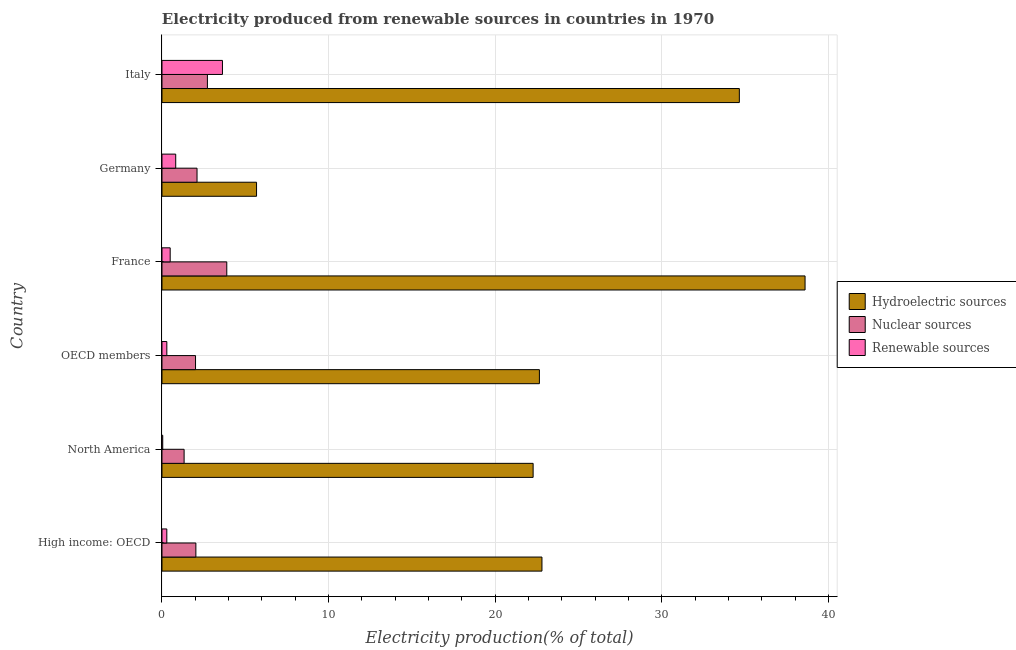How many groups of bars are there?
Your response must be concise. 6. Are the number of bars per tick equal to the number of legend labels?
Ensure brevity in your answer.  Yes. How many bars are there on the 5th tick from the top?
Your answer should be very brief. 3. How many bars are there on the 1st tick from the bottom?
Keep it short and to the point. 3. What is the label of the 2nd group of bars from the top?
Offer a terse response. Germany. In how many cases, is the number of bars for a given country not equal to the number of legend labels?
Ensure brevity in your answer.  0. What is the percentage of electricity produced by hydroelectric sources in Germany?
Your response must be concise. 5.68. Across all countries, what is the maximum percentage of electricity produced by renewable sources?
Your answer should be compact. 3.63. Across all countries, what is the minimum percentage of electricity produced by renewable sources?
Ensure brevity in your answer.  0.04. What is the total percentage of electricity produced by renewable sources in the graph?
Your answer should be compact. 5.57. What is the difference between the percentage of electricity produced by nuclear sources in High income: OECD and that in OECD members?
Offer a very short reply. 0.02. What is the difference between the percentage of electricity produced by renewable sources in OECD members and the percentage of electricity produced by hydroelectric sources in Germany?
Offer a terse response. -5.39. What is the average percentage of electricity produced by hydroelectric sources per country?
Offer a very short reply. 24.45. What is the difference between the percentage of electricity produced by hydroelectric sources and percentage of electricity produced by nuclear sources in High income: OECD?
Offer a very short reply. 20.77. What is the ratio of the percentage of electricity produced by renewable sources in Germany to that in High income: OECD?
Your response must be concise. 2.85. Is the percentage of electricity produced by renewable sources in Germany less than that in Italy?
Provide a short and direct response. Yes. What is the difference between the highest and the second highest percentage of electricity produced by hydroelectric sources?
Your answer should be compact. 3.94. What is the difference between the highest and the lowest percentage of electricity produced by hydroelectric sources?
Provide a short and direct response. 32.92. In how many countries, is the percentage of electricity produced by nuclear sources greater than the average percentage of electricity produced by nuclear sources taken over all countries?
Give a very brief answer. 2. Is the sum of the percentage of electricity produced by nuclear sources in Italy and OECD members greater than the maximum percentage of electricity produced by hydroelectric sources across all countries?
Give a very brief answer. No. What does the 3rd bar from the top in High income: OECD represents?
Give a very brief answer. Hydroelectric sources. What does the 1st bar from the bottom in France represents?
Offer a very short reply. Hydroelectric sources. How many bars are there?
Provide a succinct answer. 18. What is the difference between two consecutive major ticks on the X-axis?
Provide a short and direct response. 10. Are the values on the major ticks of X-axis written in scientific E-notation?
Offer a terse response. No. Does the graph contain grids?
Keep it short and to the point. Yes. How are the legend labels stacked?
Keep it short and to the point. Vertical. What is the title of the graph?
Provide a short and direct response. Electricity produced from renewable sources in countries in 1970. What is the label or title of the Y-axis?
Keep it short and to the point. Country. What is the Electricity production(% of total) of Hydroelectric sources in High income: OECD?
Keep it short and to the point. 22.81. What is the Electricity production(% of total) of Nuclear sources in High income: OECD?
Keep it short and to the point. 2.03. What is the Electricity production(% of total) in Renewable sources in High income: OECD?
Your answer should be compact. 0.29. What is the Electricity production(% of total) of Hydroelectric sources in North America?
Ensure brevity in your answer.  22.28. What is the Electricity production(% of total) in Nuclear sources in North America?
Offer a terse response. 1.33. What is the Electricity production(% of total) of Renewable sources in North America?
Offer a very short reply. 0.04. What is the Electricity production(% of total) in Hydroelectric sources in OECD members?
Ensure brevity in your answer.  22.65. What is the Electricity production(% of total) of Nuclear sources in OECD members?
Make the answer very short. 2.01. What is the Electricity production(% of total) of Renewable sources in OECD members?
Ensure brevity in your answer.  0.29. What is the Electricity production(% of total) of Hydroelectric sources in France?
Your answer should be very brief. 38.6. What is the Electricity production(% of total) in Nuclear sources in France?
Make the answer very short. 3.89. What is the Electricity production(% of total) in Renewable sources in France?
Give a very brief answer. 0.49. What is the Electricity production(% of total) of Hydroelectric sources in Germany?
Give a very brief answer. 5.68. What is the Electricity production(% of total) in Nuclear sources in Germany?
Your answer should be compact. 2.1. What is the Electricity production(% of total) of Renewable sources in Germany?
Keep it short and to the point. 0.82. What is the Electricity production(% of total) in Hydroelectric sources in Italy?
Offer a terse response. 34.66. What is the Electricity production(% of total) of Nuclear sources in Italy?
Offer a terse response. 2.73. What is the Electricity production(% of total) of Renewable sources in Italy?
Your response must be concise. 3.63. Across all countries, what is the maximum Electricity production(% of total) in Hydroelectric sources?
Your answer should be compact. 38.6. Across all countries, what is the maximum Electricity production(% of total) of Nuclear sources?
Ensure brevity in your answer.  3.89. Across all countries, what is the maximum Electricity production(% of total) of Renewable sources?
Keep it short and to the point. 3.63. Across all countries, what is the minimum Electricity production(% of total) of Hydroelectric sources?
Your answer should be very brief. 5.68. Across all countries, what is the minimum Electricity production(% of total) of Nuclear sources?
Offer a very short reply. 1.33. Across all countries, what is the minimum Electricity production(% of total) of Renewable sources?
Your answer should be compact. 0.04. What is the total Electricity production(% of total) of Hydroelectric sources in the graph?
Offer a terse response. 146.67. What is the total Electricity production(% of total) of Nuclear sources in the graph?
Provide a short and direct response. 14.1. What is the total Electricity production(% of total) in Renewable sources in the graph?
Keep it short and to the point. 5.57. What is the difference between the Electricity production(% of total) of Hydroelectric sources in High income: OECD and that in North America?
Offer a terse response. 0.53. What is the difference between the Electricity production(% of total) in Nuclear sources in High income: OECD and that in North America?
Ensure brevity in your answer.  0.71. What is the difference between the Electricity production(% of total) in Renewable sources in High income: OECD and that in North America?
Make the answer very short. 0.24. What is the difference between the Electricity production(% of total) in Hydroelectric sources in High income: OECD and that in OECD members?
Provide a short and direct response. 0.15. What is the difference between the Electricity production(% of total) of Nuclear sources in High income: OECD and that in OECD members?
Provide a short and direct response. 0.02. What is the difference between the Electricity production(% of total) of Renewable sources in High income: OECD and that in OECD members?
Ensure brevity in your answer.  -0. What is the difference between the Electricity production(% of total) of Hydroelectric sources in High income: OECD and that in France?
Provide a succinct answer. -15.79. What is the difference between the Electricity production(% of total) in Nuclear sources in High income: OECD and that in France?
Provide a short and direct response. -1.86. What is the difference between the Electricity production(% of total) in Renewable sources in High income: OECD and that in France?
Your answer should be very brief. -0.2. What is the difference between the Electricity production(% of total) in Hydroelectric sources in High income: OECD and that in Germany?
Ensure brevity in your answer.  17.13. What is the difference between the Electricity production(% of total) in Nuclear sources in High income: OECD and that in Germany?
Offer a terse response. -0.07. What is the difference between the Electricity production(% of total) in Renewable sources in High income: OECD and that in Germany?
Your response must be concise. -0.53. What is the difference between the Electricity production(% of total) in Hydroelectric sources in High income: OECD and that in Italy?
Offer a very short reply. -11.85. What is the difference between the Electricity production(% of total) in Nuclear sources in High income: OECD and that in Italy?
Your answer should be compact. -0.69. What is the difference between the Electricity production(% of total) in Renewable sources in High income: OECD and that in Italy?
Ensure brevity in your answer.  -3.34. What is the difference between the Electricity production(% of total) in Hydroelectric sources in North America and that in OECD members?
Your answer should be compact. -0.38. What is the difference between the Electricity production(% of total) of Nuclear sources in North America and that in OECD members?
Ensure brevity in your answer.  -0.69. What is the difference between the Electricity production(% of total) in Renewable sources in North America and that in OECD members?
Your answer should be compact. -0.25. What is the difference between the Electricity production(% of total) in Hydroelectric sources in North America and that in France?
Make the answer very short. -16.32. What is the difference between the Electricity production(% of total) in Nuclear sources in North America and that in France?
Keep it short and to the point. -2.56. What is the difference between the Electricity production(% of total) in Renewable sources in North America and that in France?
Keep it short and to the point. -0.45. What is the difference between the Electricity production(% of total) in Hydroelectric sources in North America and that in Germany?
Offer a terse response. 16.6. What is the difference between the Electricity production(% of total) of Nuclear sources in North America and that in Germany?
Your response must be concise. -0.78. What is the difference between the Electricity production(% of total) of Renewable sources in North America and that in Germany?
Your answer should be compact. -0.78. What is the difference between the Electricity production(% of total) in Hydroelectric sources in North America and that in Italy?
Your answer should be compact. -12.38. What is the difference between the Electricity production(% of total) of Nuclear sources in North America and that in Italy?
Your answer should be very brief. -1.4. What is the difference between the Electricity production(% of total) of Renewable sources in North America and that in Italy?
Your response must be concise. -3.58. What is the difference between the Electricity production(% of total) in Hydroelectric sources in OECD members and that in France?
Offer a very short reply. -15.95. What is the difference between the Electricity production(% of total) of Nuclear sources in OECD members and that in France?
Provide a succinct answer. -1.88. What is the difference between the Electricity production(% of total) of Renewable sources in OECD members and that in France?
Provide a short and direct response. -0.2. What is the difference between the Electricity production(% of total) in Hydroelectric sources in OECD members and that in Germany?
Ensure brevity in your answer.  16.98. What is the difference between the Electricity production(% of total) of Nuclear sources in OECD members and that in Germany?
Give a very brief answer. -0.09. What is the difference between the Electricity production(% of total) in Renewable sources in OECD members and that in Germany?
Offer a terse response. -0.53. What is the difference between the Electricity production(% of total) in Hydroelectric sources in OECD members and that in Italy?
Offer a very short reply. -12. What is the difference between the Electricity production(% of total) of Nuclear sources in OECD members and that in Italy?
Make the answer very short. -0.71. What is the difference between the Electricity production(% of total) in Renewable sources in OECD members and that in Italy?
Ensure brevity in your answer.  -3.34. What is the difference between the Electricity production(% of total) of Hydroelectric sources in France and that in Germany?
Make the answer very short. 32.92. What is the difference between the Electricity production(% of total) of Nuclear sources in France and that in Germany?
Provide a short and direct response. 1.79. What is the difference between the Electricity production(% of total) in Renewable sources in France and that in Germany?
Provide a succinct answer. -0.33. What is the difference between the Electricity production(% of total) of Hydroelectric sources in France and that in Italy?
Offer a terse response. 3.94. What is the difference between the Electricity production(% of total) of Nuclear sources in France and that in Italy?
Ensure brevity in your answer.  1.16. What is the difference between the Electricity production(% of total) of Renewable sources in France and that in Italy?
Ensure brevity in your answer.  -3.14. What is the difference between the Electricity production(% of total) of Hydroelectric sources in Germany and that in Italy?
Offer a very short reply. -28.98. What is the difference between the Electricity production(% of total) in Nuclear sources in Germany and that in Italy?
Your answer should be compact. -0.62. What is the difference between the Electricity production(% of total) in Renewable sources in Germany and that in Italy?
Provide a short and direct response. -2.81. What is the difference between the Electricity production(% of total) of Hydroelectric sources in High income: OECD and the Electricity production(% of total) of Nuclear sources in North America?
Your answer should be compact. 21.48. What is the difference between the Electricity production(% of total) in Hydroelectric sources in High income: OECD and the Electricity production(% of total) in Renewable sources in North America?
Your answer should be very brief. 22.76. What is the difference between the Electricity production(% of total) in Nuclear sources in High income: OECD and the Electricity production(% of total) in Renewable sources in North America?
Make the answer very short. 1.99. What is the difference between the Electricity production(% of total) of Hydroelectric sources in High income: OECD and the Electricity production(% of total) of Nuclear sources in OECD members?
Your response must be concise. 20.79. What is the difference between the Electricity production(% of total) of Hydroelectric sources in High income: OECD and the Electricity production(% of total) of Renewable sources in OECD members?
Your response must be concise. 22.52. What is the difference between the Electricity production(% of total) of Nuclear sources in High income: OECD and the Electricity production(% of total) of Renewable sources in OECD members?
Your answer should be very brief. 1.74. What is the difference between the Electricity production(% of total) of Hydroelectric sources in High income: OECD and the Electricity production(% of total) of Nuclear sources in France?
Provide a succinct answer. 18.92. What is the difference between the Electricity production(% of total) in Hydroelectric sources in High income: OECD and the Electricity production(% of total) in Renewable sources in France?
Give a very brief answer. 22.32. What is the difference between the Electricity production(% of total) of Nuclear sources in High income: OECD and the Electricity production(% of total) of Renewable sources in France?
Keep it short and to the point. 1.54. What is the difference between the Electricity production(% of total) of Hydroelectric sources in High income: OECD and the Electricity production(% of total) of Nuclear sources in Germany?
Provide a short and direct response. 20.7. What is the difference between the Electricity production(% of total) in Hydroelectric sources in High income: OECD and the Electricity production(% of total) in Renewable sources in Germany?
Your answer should be compact. 21.98. What is the difference between the Electricity production(% of total) of Nuclear sources in High income: OECD and the Electricity production(% of total) of Renewable sources in Germany?
Offer a very short reply. 1.21. What is the difference between the Electricity production(% of total) of Hydroelectric sources in High income: OECD and the Electricity production(% of total) of Nuclear sources in Italy?
Your response must be concise. 20.08. What is the difference between the Electricity production(% of total) of Hydroelectric sources in High income: OECD and the Electricity production(% of total) of Renewable sources in Italy?
Make the answer very short. 19.18. What is the difference between the Electricity production(% of total) of Nuclear sources in High income: OECD and the Electricity production(% of total) of Renewable sources in Italy?
Keep it short and to the point. -1.59. What is the difference between the Electricity production(% of total) of Hydroelectric sources in North America and the Electricity production(% of total) of Nuclear sources in OECD members?
Offer a terse response. 20.26. What is the difference between the Electricity production(% of total) of Hydroelectric sources in North America and the Electricity production(% of total) of Renewable sources in OECD members?
Offer a terse response. 21.99. What is the difference between the Electricity production(% of total) of Nuclear sources in North America and the Electricity production(% of total) of Renewable sources in OECD members?
Keep it short and to the point. 1.04. What is the difference between the Electricity production(% of total) of Hydroelectric sources in North America and the Electricity production(% of total) of Nuclear sources in France?
Give a very brief answer. 18.39. What is the difference between the Electricity production(% of total) of Hydroelectric sources in North America and the Electricity production(% of total) of Renewable sources in France?
Provide a succinct answer. 21.79. What is the difference between the Electricity production(% of total) of Nuclear sources in North America and the Electricity production(% of total) of Renewable sources in France?
Offer a terse response. 0.84. What is the difference between the Electricity production(% of total) of Hydroelectric sources in North America and the Electricity production(% of total) of Nuclear sources in Germany?
Keep it short and to the point. 20.17. What is the difference between the Electricity production(% of total) in Hydroelectric sources in North America and the Electricity production(% of total) in Renewable sources in Germany?
Keep it short and to the point. 21.45. What is the difference between the Electricity production(% of total) of Nuclear sources in North America and the Electricity production(% of total) of Renewable sources in Germany?
Give a very brief answer. 0.5. What is the difference between the Electricity production(% of total) of Hydroelectric sources in North America and the Electricity production(% of total) of Nuclear sources in Italy?
Make the answer very short. 19.55. What is the difference between the Electricity production(% of total) in Hydroelectric sources in North America and the Electricity production(% of total) in Renewable sources in Italy?
Offer a terse response. 18.65. What is the difference between the Electricity production(% of total) of Nuclear sources in North America and the Electricity production(% of total) of Renewable sources in Italy?
Provide a succinct answer. -2.3. What is the difference between the Electricity production(% of total) of Hydroelectric sources in OECD members and the Electricity production(% of total) of Nuclear sources in France?
Offer a very short reply. 18.76. What is the difference between the Electricity production(% of total) in Hydroelectric sources in OECD members and the Electricity production(% of total) in Renewable sources in France?
Make the answer very short. 22.16. What is the difference between the Electricity production(% of total) in Nuclear sources in OECD members and the Electricity production(% of total) in Renewable sources in France?
Ensure brevity in your answer.  1.52. What is the difference between the Electricity production(% of total) in Hydroelectric sources in OECD members and the Electricity production(% of total) in Nuclear sources in Germany?
Offer a very short reply. 20.55. What is the difference between the Electricity production(% of total) of Hydroelectric sources in OECD members and the Electricity production(% of total) of Renewable sources in Germany?
Make the answer very short. 21.83. What is the difference between the Electricity production(% of total) in Nuclear sources in OECD members and the Electricity production(% of total) in Renewable sources in Germany?
Your response must be concise. 1.19. What is the difference between the Electricity production(% of total) of Hydroelectric sources in OECD members and the Electricity production(% of total) of Nuclear sources in Italy?
Your answer should be compact. 19.93. What is the difference between the Electricity production(% of total) of Hydroelectric sources in OECD members and the Electricity production(% of total) of Renewable sources in Italy?
Provide a short and direct response. 19.03. What is the difference between the Electricity production(% of total) in Nuclear sources in OECD members and the Electricity production(% of total) in Renewable sources in Italy?
Keep it short and to the point. -1.62. What is the difference between the Electricity production(% of total) of Hydroelectric sources in France and the Electricity production(% of total) of Nuclear sources in Germany?
Keep it short and to the point. 36.5. What is the difference between the Electricity production(% of total) in Hydroelectric sources in France and the Electricity production(% of total) in Renewable sources in Germany?
Keep it short and to the point. 37.78. What is the difference between the Electricity production(% of total) of Nuclear sources in France and the Electricity production(% of total) of Renewable sources in Germany?
Provide a short and direct response. 3.07. What is the difference between the Electricity production(% of total) in Hydroelectric sources in France and the Electricity production(% of total) in Nuclear sources in Italy?
Your answer should be compact. 35.87. What is the difference between the Electricity production(% of total) of Hydroelectric sources in France and the Electricity production(% of total) of Renewable sources in Italy?
Your answer should be compact. 34.97. What is the difference between the Electricity production(% of total) of Nuclear sources in France and the Electricity production(% of total) of Renewable sources in Italy?
Make the answer very short. 0.26. What is the difference between the Electricity production(% of total) in Hydroelectric sources in Germany and the Electricity production(% of total) in Nuclear sources in Italy?
Keep it short and to the point. 2.95. What is the difference between the Electricity production(% of total) of Hydroelectric sources in Germany and the Electricity production(% of total) of Renewable sources in Italy?
Offer a very short reply. 2.05. What is the difference between the Electricity production(% of total) of Nuclear sources in Germany and the Electricity production(% of total) of Renewable sources in Italy?
Give a very brief answer. -1.53. What is the average Electricity production(% of total) in Hydroelectric sources per country?
Ensure brevity in your answer.  24.45. What is the average Electricity production(% of total) in Nuclear sources per country?
Make the answer very short. 2.35. What is the average Electricity production(% of total) in Renewable sources per country?
Provide a succinct answer. 0.93. What is the difference between the Electricity production(% of total) in Hydroelectric sources and Electricity production(% of total) in Nuclear sources in High income: OECD?
Offer a terse response. 20.77. What is the difference between the Electricity production(% of total) in Hydroelectric sources and Electricity production(% of total) in Renewable sources in High income: OECD?
Give a very brief answer. 22.52. What is the difference between the Electricity production(% of total) in Nuclear sources and Electricity production(% of total) in Renewable sources in High income: OECD?
Offer a terse response. 1.75. What is the difference between the Electricity production(% of total) in Hydroelectric sources and Electricity production(% of total) in Nuclear sources in North America?
Give a very brief answer. 20.95. What is the difference between the Electricity production(% of total) of Hydroelectric sources and Electricity production(% of total) of Renewable sources in North America?
Give a very brief answer. 22.23. What is the difference between the Electricity production(% of total) in Nuclear sources and Electricity production(% of total) in Renewable sources in North America?
Give a very brief answer. 1.28. What is the difference between the Electricity production(% of total) of Hydroelectric sources and Electricity production(% of total) of Nuclear sources in OECD members?
Your answer should be very brief. 20.64. What is the difference between the Electricity production(% of total) in Hydroelectric sources and Electricity production(% of total) in Renewable sources in OECD members?
Give a very brief answer. 22.36. What is the difference between the Electricity production(% of total) of Nuclear sources and Electricity production(% of total) of Renewable sources in OECD members?
Your answer should be compact. 1.72. What is the difference between the Electricity production(% of total) in Hydroelectric sources and Electricity production(% of total) in Nuclear sources in France?
Offer a terse response. 34.71. What is the difference between the Electricity production(% of total) of Hydroelectric sources and Electricity production(% of total) of Renewable sources in France?
Make the answer very short. 38.11. What is the difference between the Electricity production(% of total) of Nuclear sources and Electricity production(% of total) of Renewable sources in France?
Make the answer very short. 3.4. What is the difference between the Electricity production(% of total) in Hydroelectric sources and Electricity production(% of total) in Nuclear sources in Germany?
Give a very brief answer. 3.57. What is the difference between the Electricity production(% of total) in Hydroelectric sources and Electricity production(% of total) in Renewable sources in Germany?
Offer a terse response. 4.85. What is the difference between the Electricity production(% of total) of Nuclear sources and Electricity production(% of total) of Renewable sources in Germany?
Offer a very short reply. 1.28. What is the difference between the Electricity production(% of total) in Hydroelectric sources and Electricity production(% of total) in Nuclear sources in Italy?
Offer a very short reply. 31.93. What is the difference between the Electricity production(% of total) of Hydroelectric sources and Electricity production(% of total) of Renewable sources in Italy?
Your answer should be compact. 31.03. What is the difference between the Electricity production(% of total) in Nuclear sources and Electricity production(% of total) in Renewable sources in Italy?
Make the answer very short. -0.9. What is the ratio of the Electricity production(% of total) in Hydroelectric sources in High income: OECD to that in North America?
Your answer should be very brief. 1.02. What is the ratio of the Electricity production(% of total) in Nuclear sources in High income: OECD to that in North America?
Offer a terse response. 1.53. What is the ratio of the Electricity production(% of total) in Renewable sources in High income: OECD to that in North America?
Offer a very short reply. 6.5. What is the ratio of the Electricity production(% of total) of Hydroelectric sources in High income: OECD to that in OECD members?
Your answer should be compact. 1.01. What is the ratio of the Electricity production(% of total) in Nuclear sources in High income: OECD to that in OECD members?
Offer a terse response. 1.01. What is the ratio of the Electricity production(% of total) in Hydroelectric sources in High income: OECD to that in France?
Ensure brevity in your answer.  0.59. What is the ratio of the Electricity production(% of total) in Nuclear sources in High income: OECD to that in France?
Offer a very short reply. 0.52. What is the ratio of the Electricity production(% of total) in Renewable sources in High income: OECD to that in France?
Your answer should be compact. 0.59. What is the ratio of the Electricity production(% of total) of Hydroelectric sources in High income: OECD to that in Germany?
Give a very brief answer. 4.02. What is the ratio of the Electricity production(% of total) of Nuclear sources in High income: OECD to that in Germany?
Your response must be concise. 0.97. What is the ratio of the Electricity production(% of total) in Renewable sources in High income: OECD to that in Germany?
Your answer should be compact. 0.35. What is the ratio of the Electricity production(% of total) in Hydroelectric sources in High income: OECD to that in Italy?
Offer a very short reply. 0.66. What is the ratio of the Electricity production(% of total) of Nuclear sources in High income: OECD to that in Italy?
Provide a succinct answer. 0.75. What is the ratio of the Electricity production(% of total) of Renewable sources in High income: OECD to that in Italy?
Give a very brief answer. 0.08. What is the ratio of the Electricity production(% of total) in Hydroelectric sources in North America to that in OECD members?
Offer a terse response. 0.98. What is the ratio of the Electricity production(% of total) in Nuclear sources in North America to that in OECD members?
Ensure brevity in your answer.  0.66. What is the ratio of the Electricity production(% of total) of Renewable sources in North America to that in OECD members?
Make the answer very short. 0.15. What is the ratio of the Electricity production(% of total) in Hydroelectric sources in North America to that in France?
Make the answer very short. 0.58. What is the ratio of the Electricity production(% of total) in Nuclear sources in North America to that in France?
Provide a short and direct response. 0.34. What is the ratio of the Electricity production(% of total) of Renewable sources in North America to that in France?
Your answer should be compact. 0.09. What is the ratio of the Electricity production(% of total) in Hydroelectric sources in North America to that in Germany?
Your answer should be very brief. 3.92. What is the ratio of the Electricity production(% of total) of Nuclear sources in North America to that in Germany?
Your response must be concise. 0.63. What is the ratio of the Electricity production(% of total) in Renewable sources in North America to that in Germany?
Your answer should be very brief. 0.05. What is the ratio of the Electricity production(% of total) of Hydroelectric sources in North America to that in Italy?
Ensure brevity in your answer.  0.64. What is the ratio of the Electricity production(% of total) in Nuclear sources in North America to that in Italy?
Offer a very short reply. 0.49. What is the ratio of the Electricity production(% of total) in Renewable sources in North America to that in Italy?
Make the answer very short. 0.01. What is the ratio of the Electricity production(% of total) of Hydroelectric sources in OECD members to that in France?
Offer a terse response. 0.59. What is the ratio of the Electricity production(% of total) of Nuclear sources in OECD members to that in France?
Ensure brevity in your answer.  0.52. What is the ratio of the Electricity production(% of total) in Renewable sources in OECD members to that in France?
Your answer should be compact. 0.59. What is the ratio of the Electricity production(% of total) in Hydroelectric sources in OECD members to that in Germany?
Offer a terse response. 3.99. What is the ratio of the Electricity production(% of total) of Nuclear sources in OECD members to that in Germany?
Your answer should be compact. 0.96. What is the ratio of the Electricity production(% of total) of Renewable sources in OECD members to that in Germany?
Provide a short and direct response. 0.35. What is the ratio of the Electricity production(% of total) of Hydroelectric sources in OECD members to that in Italy?
Make the answer very short. 0.65. What is the ratio of the Electricity production(% of total) in Nuclear sources in OECD members to that in Italy?
Give a very brief answer. 0.74. What is the ratio of the Electricity production(% of total) of Renewable sources in OECD members to that in Italy?
Provide a short and direct response. 0.08. What is the ratio of the Electricity production(% of total) of Hydroelectric sources in France to that in Germany?
Ensure brevity in your answer.  6.8. What is the ratio of the Electricity production(% of total) of Nuclear sources in France to that in Germany?
Provide a short and direct response. 1.85. What is the ratio of the Electricity production(% of total) of Renewable sources in France to that in Germany?
Make the answer very short. 0.6. What is the ratio of the Electricity production(% of total) in Hydroelectric sources in France to that in Italy?
Your answer should be compact. 1.11. What is the ratio of the Electricity production(% of total) of Nuclear sources in France to that in Italy?
Give a very brief answer. 1.43. What is the ratio of the Electricity production(% of total) of Renewable sources in France to that in Italy?
Make the answer very short. 0.14. What is the ratio of the Electricity production(% of total) in Hydroelectric sources in Germany to that in Italy?
Your answer should be very brief. 0.16. What is the ratio of the Electricity production(% of total) of Nuclear sources in Germany to that in Italy?
Keep it short and to the point. 0.77. What is the ratio of the Electricity production(% of total) of Renewable sources in Germany to that in Italy?
Provide a short and direct response. 0.23. What is the difference between the highest and the second highest Electricity production(% of total) of Hydroelectric sources?
Your answer should be very brief. 3.94. What is the difference between the highest and the second highest Electricity production(% of total) of Nuclear sources?
Ensure brevity in your answer.  1.16. What is the difference between the highest and the second highest Electricity production(% of total) of Renewable sources?
Keep it short and to the point. 2.81. What is the difference between the highest and the lowest Electricity production(% of total) in Hydroelectric sources?
Give a very brief answer. 32.92. What is the difference between the highest and the lowest Electricity production(% of total) in Nuclear sources?
Keep it short and to the point. 2.56. What is the difference between the highest and the lowest Electricity production(% of total) in Renewable sources?
Your response must be concise. 3.58. 